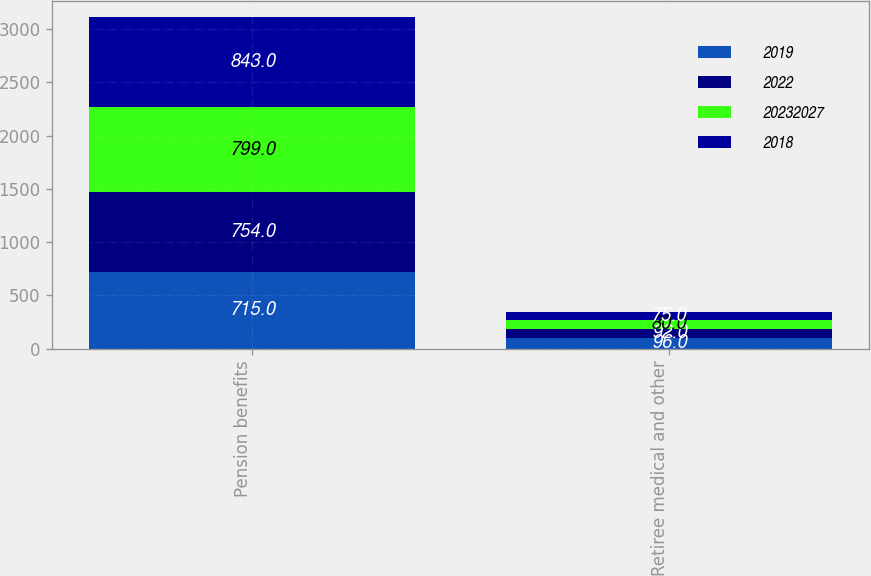Convert chart to OTSL. <chart><loc_0><loc_0><loc_500><loc_500><stacked_bar_chart><ecel><fcel>Pension benefits<fcel>Retiree medical and other<nl><fcel>2019<fcel>715<fcel>96<nl><fcel>2022<fcel>754<fcel>92<nl><fcel>2.0232e+07<fcel>799<fcel>80<nl><fcel>2018<fcel>843<fcel>75<nl></chart> 